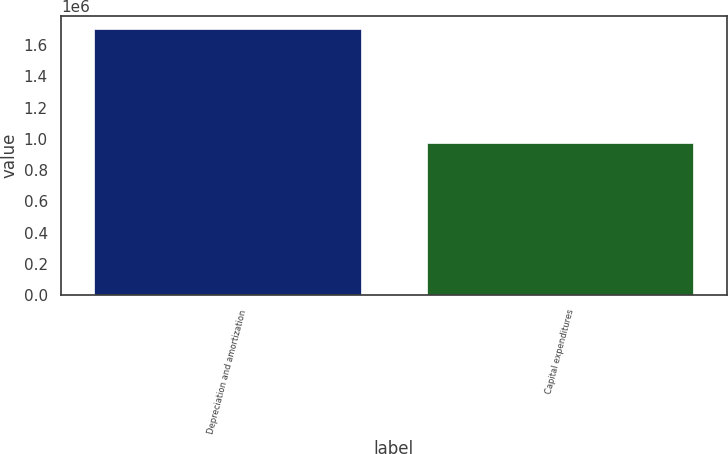Convert chart to OTSL. <chart><loc_0><loc_0><loc_500><loc_500><bar_chart><fcel>Depreciation and amortization<fcel>Capital expenditures<nl><fcel>1.70005e+06<fcel>973301<nl></chart> 